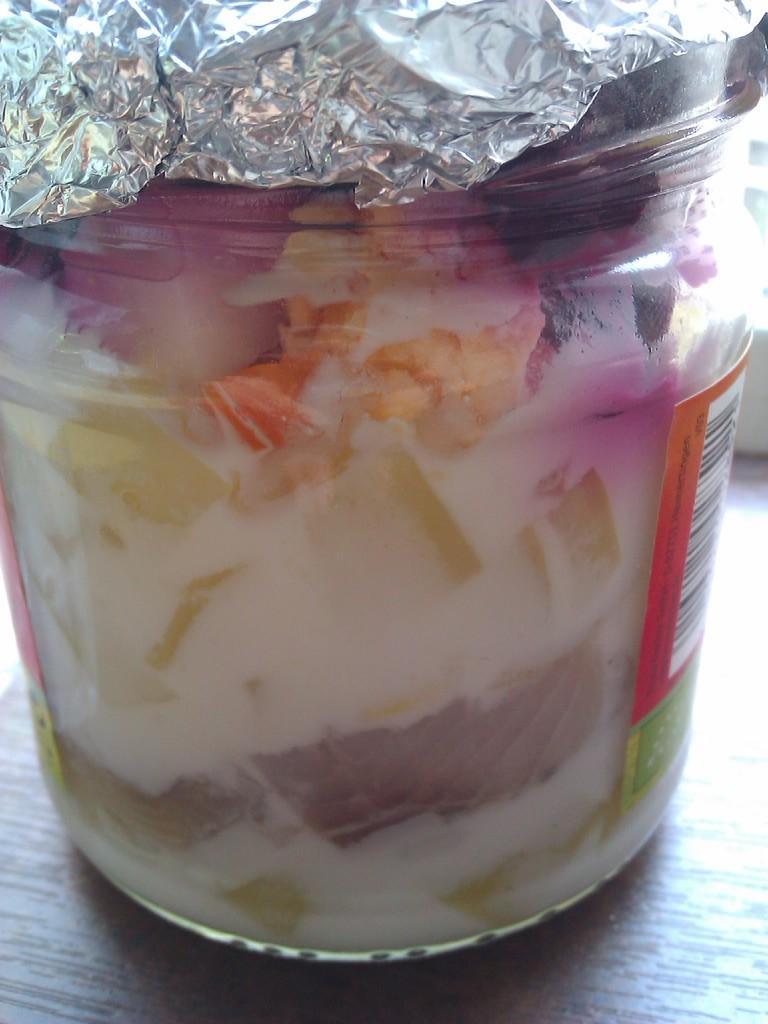In one or two sentences, can you explain what this image depicts? In this picture we can see a jar with food in it and on this jar we can see an aluminium foil and this jar is placed on a wooden surface. 